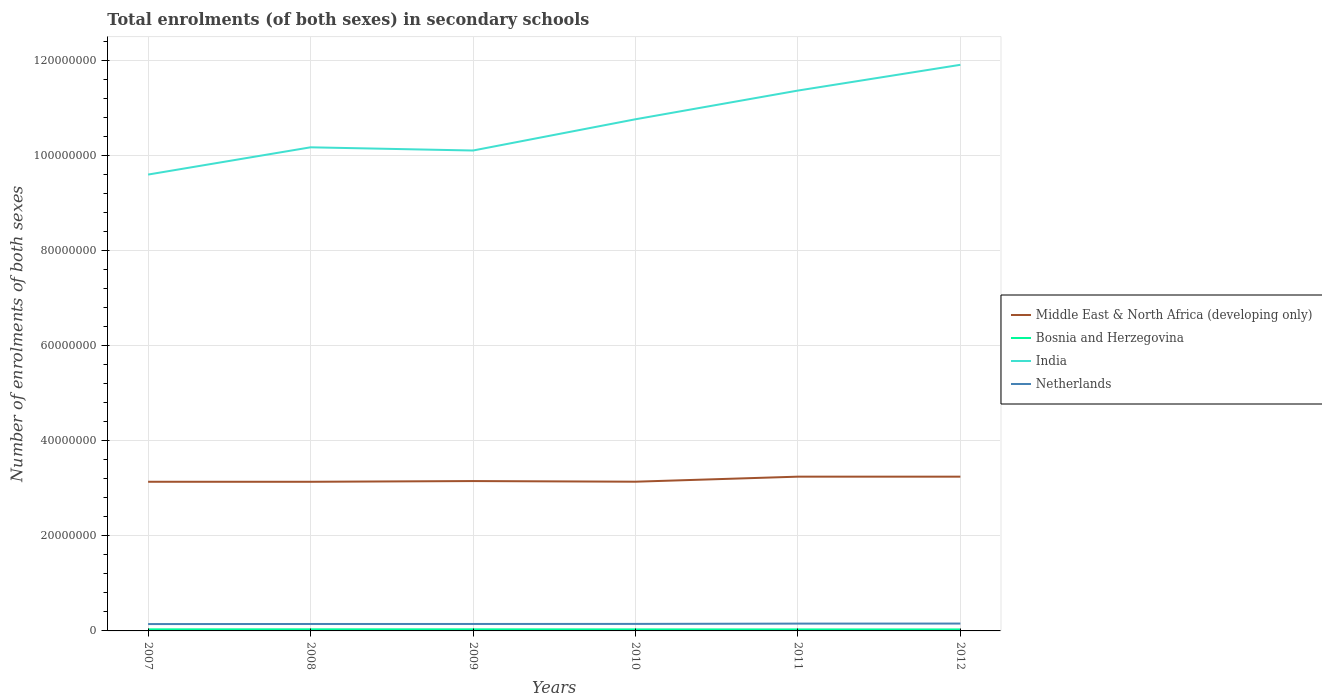How many different coloured lines are there?
Your answer should be very brief. 4. Is the number of lines equal to the number of legend labels?
Your response must be concise. Yes. Across all years, what is the maximum number of enrolments in secondary schools in Bosnia and Herzegovina?
Provide a succinct answer. 3.13e+05. What is the total number of enrolments in secondary schools in Netherlands in the graph?
Make the answer very short. -1.84e+04. What is the difference between the highest and the second highest number of enrolments in secondary schools in India?
Provide a short and direct response. 2.31e+07. How many lines are there?
Your response must be concise. 4. Are the values on the major ticks of Y-axis written in scientific E-notation?
Provide a succinct answer. No. Does the graph contain any zero values?
Make the answer very short. No. How are the legend labels stacked?
Offer a very short reply. Vertical. What is the title of the graph?
Ensure brevity in your answer.  Total enrolments (of both sexes) in secondary schools. Does "Samoa" appear as one of the legend labels in the graph?
Give a very brief answer. No. What is the label or title of the X-axis?
Offer a terse response. Years. What is the label or title of the Y-axis?
Give a very brief answer. Number of enrolments of both sexes. What is the Number of enrolments of both sexes in Middle East & North Africa (developing only) in 2007?
Your answer should be very brief. 3.14e+07. What is the Number of enrolments of both sexes in Bosnia and Herzegovina in 2007?
Give a very brief answer. 3.33e+05. What is the Number of enrolments of both sexes in India in 2007?
Offer a terse response. 9.60e+07. What is the Number of enrolments of both sexes of Netherlands in 2007?
Keep it short and to the point. 1.44e+06. What is the Number of enrolments of both sexes in Middle East & North Africa (developing only) in 2008?
Offer a terse response. 3.14e+07. What is the Number of enrolments of both sexes in Bosnia and Herzegovina in 2008?
Your answer should be compact. 3.39e+05. What is the Number of enrolments of both sexes in India in 2008?
Ensure brevity in your answer.  1.02e+08. What is the Number of enrolments of both sexes of Netherlands in 2008?
Offer a very short reply. 1.46e+06. What is the Number of enrolments of both sexes of Middle East & North Africa (developing only) in 2009?
Your answer should be very brief. 3.15e+07. What is the Number of enrolments of both sexes of Bosnia and Herzegovina in 2009?
Give a very brief answer. 3.34e+05. What is the Number of enrolments of both sexes in India in 2009?
Offer a terse response. 1.01e+08. What is the Number of enrolments of both sexes in Netherlands in 2009?
Your answer should be very brief. 1.46e+06. What is the Number of enrolments of both sexes in Middle East & North Africa (developing only) in 2010?
Keep it short and to the point. 3.14e+07. What is the Number of enrolments of both sexes of Bosnia and Herzegovina in 2010?
Your answer should be very brief. 3.23e+05. What is the Number of enrolments of both sexes of India in 2010?
Make the answer very short. 1.08e+08. What is the Number of enrolments of both sexes of Netherlands in 2010?
Offer a very short reply. 1.47e+06. What is the Number of enrolments of both sexes of Middle East & North Africa (developing only) in 2011?
Provide a succinct answer. 3.25e+07. What is the Number of enrolments of both sexes of Bosnia and Herzegovina in 2011?
Offer a terse response. 3.16e+05. What is the Number of enrolments of both sexes in India in 2011?
Offer a very short reply. 1.14e+08. What is the Number of enrolments of both sexes in Netherlands in 2011?
Offer a terse response. 1.54e+06. What is the Number of enrolments of both sexes in Middle East & North Africa (developing only) in 2012?
Provide a short and direct response. 3.25e+07. What is the Number of enrolments of both sexes of Bosnia and Herzegovina in 2012?
Provide a short and direct response. 3.13e+05. What is the Number of enrolments of both sexes in India in 2012?
Your answer should be very brief. 1.19e+08. What is the Number of enrolments of both sexes of Netherlands in 2012?
Give a very brief answer. 1.55e+06. Across all years, what is the maximum Number of enrolments of both sexes in Middle East & North Africa (developing only)?
Provide a succinct answer. 3.25e+07. Across all years, what is the maximum Number of enrolments of both sexes of Bosnia and Herzegovina?
Your response must be concise. 3.39e+05. Across all years, what is the maximum Number of enrolments of both sexes in India?
Your answer should be very brief. 1.19e+08. Across all years, what is the maximum Number of enrolments of both sexes of Netherlands?
Ensure brevity in your answer.  1.55e+06. Across all years, what is the minimum Number of enrolments of both sexes in Middle East & North Africa (developing only)?
Your answer should be very brief. 3.14e+07. Across all years, what is the minimum Number of enrolments of both sexes in Bosnia and Herzegovina?
Provide a short and direct response. 3.13e+05. Across all years, what is the minimum Number of enrolments of both sexes of India?
Provide a succinct answer. 9.60e+07. Across all years, what is the minimum Number of enrolments of both sexes of Netherlands?
Your response must be concise. 1.44e+06. What is the total Number of enrolments of both sexes in Middle East & North Africa (developing only) in the graph?
Offer a terse response. 1.91e+08. What is the total Number of enrolments of both sexes in Bosnia and Herzegovina in the graph?
Offer a very short reply. 1.96e+06. What is the total Number of enrolments of both sexes in India in the graph?
Your answer should be compact. 6.40e+08. What is the total Number of enrolments of both sexes in Netherlands in the graph?
Make the answer very short. 8.93e+06. What is the difference between the Number of enrolments of both sexes in Middle East & North Africa (developing only) in 2007 and that in 2008?
Make the answer very short. 4172. What is the difference between the Number of enrolments of both sexes in Bosnia and Herzegovina in 2007 and that in 2008?
Provide a short and direct response. -5667. What is the difference between the Number of enrolments of both sexes in India in 2007 and that in 2008?
Provide a succinct answer. -5.73e+06. What is the difference between the Number of enrolments of both sexes of Netherlands in 2007 and that in 2008?
Your answer should be very brief. -1.64e+04. What is the difference between the Number of enrolments of both sexes in Middle East & North Africa (developing only) in 2007 and that in 2009?
Provide a short and direct response. -1.48e+05. What is the difference between the Number of enrolments of both sexes in Bosnia and Herzegovina in 2007 and that in 2009?
Make the answer very short. -1051. What is the difference between the Number of enrolments of both sexes of India in 2007 and that in 2009?
Offer a terse response. -5.06e+06. What is the difference between the Number of enrolments of both sexes in Netherlands in 2007 and that in 2009?
Keep it short and to the point. -1.84e+04. What is the difference between the Number of enrolments of both sexes in Middle East & North Africa (developing only) in 2007 and that in 2010?
Make the answer very short. -1.16e+04. What is the difference between the Number of enrolments of both sexes in Bosnia and Herzegovina in 2007 and that in 2010?
Ensure brevity in your answer.  1.05e+04. What is the difference between the Number of enrolments of both sexes in India in 2007 and that in 2010?
Ensure brevity in your answer.  -1.16e+07. What is the difference between the Number of enrolments of both sexes in Netherlands in 2007 and that in 2010?
Give a very brief answer. -3.09e+04. What is the difference between the Number of enrolments of both sexes of Middle East & North Africa (developing only) in 2007 and that in 2011?
Offer a terse response. -1.08e+06. What is the difference between the Number of enrolments of both sexes of Bosnia and Herzegovina in 2007 and that in 2011?
Make the answer very short. 1.71e+04. What is the difference between the Number of enrolments of both sexes of India in 2007 and that in 2011?
Provide a short and direct response. -1.77e+07. What is the difference between the Number of enrolments of both sexes of Netherlands in 2007 and that in 2011?
Your response must be concise. -9.48e+04. What is the difference between the Number of enrolments of both sexes in Middle East & North Africa (developing only) in 2007 and that in 2012?
Offer a terse response. -1.07e+06. What is the difference between the Number of enrolments of both sexes of Bosnia and Herzegovina in 2007 and that in 2012?
Make the answer very short. 2.00e+04. What is the difference between the Number of enrolments of both sexes in India in 2007 and that in 2012?
Give a very brief answer. -2.31e+07. What is the difference between the Number of enrolments of both sexes of Netherlands in 2007 and that in 2012?
Your answer should be compact. -1.06e+05. What is the difference between the Number of enrolments of both sexes of Middle East & North Africa (developing only) in 2008 and that in 2009?
Offer a terse response. -1.52e+05. What is the difference between the Number of enrolments of both sexes in Bosnia and Herzegovina in 2008 and that in 2009?
Give a very brief answer. 4616. What is the difference between the Number of enrolments of both sexes in India in 2008 and that in 2009?
Your response must be concise. 6.74e+05. What is the difference between the Number of enrolments of both sexes of Netherlands in 2008 and that in 2009?
Ensure brevity in your answer.  -1958. What is the difference between the Number of enrolments of both sexes in Middle East & North Africa (developing only) in 2008 and that in 2010?
Provide a succinct answer. -1.58e+04. What is the difference between the Number of enrolments of both sexes of Bosnia and Herzegovina in 2008 and that in 2010?
Give a very brief answer. 1.62e+04. What is the difference between the Number of enrolments of both sexes of India in 2008 and that in 2010?
Your answer should be very brief. -5.90e+06. What is the difference between the Number of enrolments of both sexes in Netherlands in 2008 and that in 2010?
Offer a terse response. -1.45e+04. What is the difference between the Number of enrolments of both sexes of Middle East & North Africa (developing only) in 2008 and that in 2011?
Your answer should be very brief. -1.08e+06. What is the difference between the Number of enrolments of both sexes of Bosnia and Herzegovina in 2008 and that in 2011?
Provide a short and direct response. 2.27e+04. What is the difference between the Number of enrolments of both sexes in India in 2008 and that in 2011?
Keep it short and to the point. -1.19e+07. What is the difference between the Number of enrolments of both sexes of Netherlands in 2008 and that in 2011?
Your answer should be very brief. -7.84e+04. What is the difference between the Number of enrolments of both sexes in Middle East & North Africa (developing only) in 2008 and that in 2012?
Make the answer very short. -1.08e+06. What is the difference between the Number of enrolments of both sexes of Bosnia and Herzegovina in 2008 and that in 2012?
Your answer should be very brief. 2.56e+04. What is the difference between the Number of enrolments of both sexes in India in 2008 and that in 2012?
Give a very brief answer. -1.74e+07. What is the difference between the Number of enrolments of both sexes of Netherlands in 2008 and that in 2012?
Your answer should be compact. -8.97e+04. What is the difference between the Number of enrolments of both sexes of Middle East & North Africa (developing only) in 2009 and that in 2010?
Give a very brief answer. 1.36e+05. What is the difference between the Number of enrolments of both sexes in Bosnia and Herzegovina in 2009 and that in 2010?
Offer a terse response. 1.16e+04. What is the difference between the Number of enrolments of both sexes in India in 2009 and that in 2010?
Your answer should be very brief. -6.58e+06. What is the difference between the Number of enrolments of both sexes in Netherlands in 2009 and that in 2010?
Keep it short and to the point. -1.25e+04. What is the difference between the Number of enrolments of both sexes of Middle East & North Africa (developing only) in 2009 and that in 2011?
Offer a terse response. -9.28e+05. What is the difference between the Number of enrolments of both sexes in Bosnia and Herzegovina in 2009 and that in 2011?
Keep it short and to the point. 1.81e+04. What is the difference between the Number of enrolments of both sexes in India in 2009 and that in 2011?
Offer a very short reply. -1.26e+07. What is the difference between the Number of enrolments of both sexes in Netherlands in 2009 and that in 2011?
Your answer should be compact. -7.64e+04. What is the difference between the Number of enrolments of both sexes in Middle East & North Africa (developing only) in 2009 and that in 2012?
Provide a short and direct response. -9.24e+05. What is the difference between the Number of enrolments of both sexes in Bosnia and Herzegovina in 2009 and that in 2012?
Offer a very short reply. 2.10e+04. What is the difference between the Number of enrolments of both sexes of India in 2009 and that in 2012?
Provide a succinct answer. -1.80e+07. What is the difference between the Number of enrolments of both sexes in Netherlands in 2009 and that in 2012?
Give a very brief answer. -8.77e+04. What is the difference between the Number of enrolments of both sexes in Middle East & North Africa (developing only) in 2010 and that in 2011?
Ensure brevity in your answer.  -1.06e+06. What is the difference between the Number of enrolments of both sexes of Bosnia and Herzegovina in 2010 and that in 2011?
Your answer should be very brief. 6525. What is the difference between the Number of enrolments of both sexes of India in 2010 and that in 2011?
Keep it short and to the point. -6.04e+06. What is the difference between the Number of enrolments of both sexes of Netherlands in 2010 and that in 2011?
Your response must be concise. -6.39e+04. What is the difference between the Number of enrolments of both sexes in Middle East & North Africa (developing only) in 2010 and that in 2012?
Your answer should be compact. -1.06e+06. What is the difference between the Number of enrolments of both sexes in Bosnia and Herzegovina in 2010 and that in 2012?
Provide a succinct answer. 9445. What is the difference between the Number of enrolments of both sexes in India in 2010 and that in 2012?
Offer a terse response. -1.15e+07. What is the difference between the Number of enrolments of both sexes of Netherlands in 2010 and that in 2012?
Give a very brief answer. -7.52e+04. What is the difference between the Number of enrolments of both sexes in Middle East & North Africa (developing only) in 2011 and that in 2012?
Your response must be concise. 3830. What is the difference between the Number of enrolments of both sexes of Bosnia and Herzegovina in 2011 and that in 2012?
Ensure brevity in your answer.  2920. What is the difference between the Number of enrolments of both sexes of India in 2011 and that in 2012?
Your answer should be very brief. -5.42e+06. What is the difference between the Number of enrolments of both sexes of Netherlands in 2011 and that in 2012?
Offer a very short reply. -1.13e+04. What is the difference between the Number of enrolments of both sexes in Middle East & North Africa (developing only) in 2007 and the Number of enrolments of both sexes in Bosnia and Herzegovina in 2008?
Make the answer very short. 3.11e+07. What is the difference between the Number of enrolments of both sexes of Middle East & North Africa (developing only) in 2007 and the Number of enrolments of both sexes of India in 2008?
Offer a very short reply. -7.04e+07. What is the difference between the Number of enrolments of both sexes of Middle East & North Africa (developing only) in 2007 and the Number of enrolments of both sexes of Netherlands in 2008?
Provide a succinct answer. 2.99e+07. What is the difference between the Number of enrolments of both sexes of Bosnia and Herzegovina in 2007 and the Number of enrolments of both sexes of India in 2008?
Make the answer very short. -1.01e+08. What is the difference between the Number of enrolments of both sexes of Bosnia and Herzegovina in 2007 and the Number of enrolments of both sexes of Netherlands in 2008?
Make the answer very short. -1.13e+06. What is the difference between the Number of enrolments of both sexes in India in 2007 and the Number of enrolments of both sexes in Netherlands in 2008?
Keep it short and to the point. 9.46e+07. What is the difference between the Number of enrolments of both sexes of Middle East & North Africa (developing only) in 2007 and the Number of enrolments of both sexes of Bosnia and Herzegovina in 2009?
Your answer should be compact. 3.11e+07. What is the difference between the Number of enrolments of both sexes in Middle East & North Africa (developing only) in 2007 and the Number of enrolments of both sexes in India in 2009?
Your answer should be very brief. -6.97e+07. What is the difference between the Number of enrolments of both sexes in Middle East & North Africa (developing only) in 2007 and the Number of enrolments of both sexes in Netherlands in 2009?
Ensure brevity in your answer.  2.99e+07. What is the difference between the Number of enrolments of both sexes in Bosnia and Herzegovina in 2007 and the Number of enrolments of both sexes in India in 2009?
Your answer should be very brief. -1.01e+08. What is the difference between the Number of enrolments of both sexes of Bosnia and Herzegovina in 2007 and the Number of enrolments of both sexes of Netherlands in 2009?
Offer a very short reply. -1.13e+06. What is the difference between the Number of enrolments of both sexes in India in 2007 and the Number of enrolments of both sexes in Netherlands in 2009?
Give a very brief answer. 9.46e+07. What is the difference between the Number of enrolments of both sexes of Middle East & North Africa (developing only) in 2007 and the Number of enrolments of both sexes of Bosnia and Herzegovina in 2010?
Keep it short and to the point. 3.11e+07. What is the difference between the Number of enrolments of both sexes of Middle East & North Africa (developing only) in 2007 and the Number of enrolments of both sexes of India in 2010?
Your answer should be very brief. -7.63e+07. What is the difference between the Number of enrolments of both sexes in Middle East & North Africa (developing only) in 2007 and the Number of enrolments of both sexes in Netherlands in 2010?
Offer a very short reply. 2.99e+07. What is the difference between the Number of enrolments of both sexes in Bosnia and Herzegovina in 2007 and the Number of enrolments of both sexes in India in 2010?
Your response must be concise. -1.07e+08. What is the difference between the Number of enrolments of both sexes of Bosnia and Herzegovina in 2007 and the Number of enrolments of both sexes of Netherlands in 2010?
Ensure brevity in your answer.  -1.14e+06. What is the difference between the Number of enrolments of both sexes of India in 2007 and the Number of enrolments of both sexes of Netherlands in 2010?
Give a very brief answer. 9.46e+07. What is the difference between the Number of enrolments of both sexes in Middle East & North Africa (developing only) in 2007 and the Number of enrolments of both sexes in Bosnia and Herzegovina in 2011?
Keep it short and to the point. 3.11e+07. What is the difference between the Number of enrolments of both sexes in Middle East & North Africa (developing only) in 2007 and the Number of enrolments of both sexes in India in 2011?
Provide a short and direct response. -8.23e+07. What is the difference between the Number of enrolments of both sexes in Middle East & North Africa (developing only) in 2007 and the Number of enrolments of both sexes in Netherlands in 2011?
Ensure brevity in your answer.  2.99e+07. What is the difference between the Number of enrolments of both sexes of Bosnia and Herzegovina in 2007 and the Number of enrolments of both sexes of India in 2011?
Give a very brief answer. -1.13e+08. What is the difference between the Number of enrolments of both sexes of Bosnia and Herzegovina in 2007 and the Number of enrolments of both sexes of Netherlands in 2011?
Offer a terse response. -1.21e+06. What is the difference between the Number of enrolments of both sexes of India in 2007 and the Number of enrolments of both sexes of Netherlands in 2011?
Your answer should be compact. 9.45e+07. What is the difference between the Number of enrolments of both sexes of Middle East & North Africa (developing only) in 2007 and the Number of enrolments of both sexes of Bosnia and Herzegovina in 2012?
Your answer should be compact. 3.11e+07. What is the difference between the Number of enrolments of both sexes of Middle East & North Africa (developing only) in 2007 and the Number of enrolments of both sexes of India in 2012?
Your response must be concise. -8.78e+07. What is the difference between the Number of enrolments of both sexes in Middle East & North Africa (developing only) in 2007 and the Number of enrolments of both sexes in Netherlands in 2012?
Your answer should be compact. 2.98e+07. What is the difference between the Number of enrolments of both sexes in Bosnia and Herzegovina in 2007 and the Number of enrolments of both sexes in India in 2012?
Offer a terse response. -1.19e+08. What is the difference between the Number of enrolments of both sexes of Bosnia and Herzegovina in 2007 and the Number of enrolments of both sexes of Netherlands in 2012?
Provide a short and direct response. -1.22e+06. What is the difference between the Number of enrolments of both sexes of India in 2007 and the Number of enrolments of both sexes of Netherlands in 2012?
Your answer should be compact. 9.45e+07. What is the difference between the Number of enrolments of both sexes of Middle East & North Africa (developing only) in 2008 and the Number of enrolments of both sexes of Bosnia and Herzegovina in 2009?
Ensure brevity in your answer.  3.11e+07. What is the difference between the Number of enrolments of both sexes in Middle East & North Africa (developing only) in 2008 and the Number of enrolments of both sexes in India in 2009?
Offer a very short reply. -6.97e+07. What is the difference between the Number of enrolments of both sexes of Middle East & North Africa (developing only) in 2008 and the Number of enrolments of both sexes of Netherlands in 2009?
Keep it short and to the point. 2.99e+07. What is the difference between the Number of enrolments of both sexes in Bosnia and Herzegovina in 2008 and the Number of enrolments of both sexes in India in 2009?
Your response must be concise. -1.01e+08. What is the difference between the Number of enrolments of both sexes in Bosnia and Herzegovina in 2008 and the Number of enrolments of both sexes in Netherlands in 2009?
Keep it short and to the point. -1.12e+06. What is the difference between the Number of enrolments of both sexes in India in 2008 and the Number of enrolments of both sexes in Netherlands in 2009?
Offer a terse response. 1.00e+08. What is the difference between the Number of enrolments of both sexes of Middle East & North Africa (developing only) in 2008 and the Number of enrolments of both sexes of Bosnia and Herzegovina in 2010?
Offer a terse response. 3.11e+07. What is the difference between the Number of enrolments of both sexes in Middle East & North Africa (developing only) in 2008 and the Number of enrolments of both sexes in India in 2010?
Your response must be concise. -7.63e+07. What is the difference between the Number of enrolments of both sexes of Middle East & North Africa (developing only) in 2008 and the Number of enrolments of both sexes of Netherlands in 2010?
Ensure brevity in your answer.  2.99e+07. What is the difference between the Number of enrolments of both sexes of Bosnia and Herzegovina in 2008 and the Number of enrolments of both sexes of India in 2010?
Make the answer very short. -1.07e+08. What is the difference between the Number of enrolments of both sexes of Bosnia and Herzegovina in 2008 and the Number of enrolments of both sexes of Netherlands in 2010?
Provide a short and direct response. -1.14e+06. What is the difference between the Number of enrolments of both sexes in India in 2008 and the Number of enrolments of both sexes in Netherlands in 2010?
Your response must be concise. 1.00e+08. What is the difference between the Number of enrolments of both sexes of Middle East & North Africa (developing only) in 2008 and the Number of enrolments of both sexes of Bosnia and Herzegovina in 2011?
Provide a short and direct response. 3.11e+07. What is the difference between the Number of enrolments of both sexes of Middle East & North Africa (developing only) in 2008 and the Number of enrolments of both sexes of India in 2011?
Provide a short and direct response. -8.23e+07. What is the difference between the Number of enrolments of both sexes of Middle East & North Africa (developing only) in 2008 and the Number of enrolments of both sexes of Netherlands in 2011?
Your answer should be very brief. 2.98e+07. What is the difference between the Number of enrolments of both sexes of Bosnia and Herzegovina in 2008 and the Number of enrolments of both sexes of India in 2011?
Ensure brevity in your answer.  -1.13e+08. What is the difference between the Number of enrolments of both sexes in Bosnia and Herzegovina in 2008 and the Number of enrolments of both sexes in Netherlands in 2011?
Make the answer very short. -1.20e+06. What is the difference between the Number of enrolments of both sexes in India in 2008 and the Number of enrolments of both sexes in Netherlands in 2011?
Provide a short and direct response. 1.00e+08. What is the difference between the Number of enrolments of both sexes in Middle East & North Africa (developing only) in 2008 and the Number of enrolments of both sexes in Bosnia and Herzegovina in 2012?
Provide a short and direct response. 3.11e+07. What is the difference between the Number of enrolments of both sexes of Middle East & North Africa (developing only) in 2008 and the Number of enrolments of both sexes of India in 2012?
Provide a short and direct response. -8.78e+07. What is the difference between the Number of enrolments of both sexes of Middle East & North Africa (developing only) in 2008 and the Number of enrolments of both sexes of Netherlands in 2012?
Make the answer very short. 2.98e+07. What is the difference between the Number of enrolments of both sexes of Bosnia and Herzegovina in 2008 and the Number of enrolments of both sexes of India in 2012?
Your answer should be very brief. -1.19e+08. What is the difference between the Number of enrolments of both sexes of Bosnia and Herzegovina in 2008 and the Number of enrolments of both sexes of Netherlands in 2012?
Ensure brevity in your answer.  -1.21e+06. What is the difference between the Number of enrolments of both sexes of India in 2008 and the Number of enrolments of both sexes of Netherlands in 2012?
Make the answer very short. 1.00e+08. What is the difference between the Number of enrolments of both sexes of Middle East & North Africa (developing only) in 2009 and the Number of enrolments of both sexes of Bosnia and Herzegovina in 2010?
Provide a succinct answer. 3.12e+07. What is the difference between the Number of enrolments of both sexes in Middle East & North Africa (developing only) in 2009 and the Number of enrolments of both sexes in India in 2010?
Provide a succinct answer. -7.61e+07. What is the difference between the Number of enrolments of both sexes of Middle East & North Africa (developing only) in 2009 and the Number of enrolments of both sexes of Netherlands in 2010?
Make the answer very short. 3.01e+07. What is the difference between the Number of enrolments of both sexes in Bosnia and Herzegovina in 2009 and the Number of enrolments of both sexes in India in 2010?
Offer a terse response. -1.07e+08. What is the difference between the Number of enrolments of both sexes of Bosnia and Herzegovina in 2009 and the Number of enrolments of both sexes of Netherlands in 2010?
Your answer should be compact. -1.14e+06. What is the difference between the Number of enrolments of both sexes in India in 2009 and the Number of enrolments of both sexes in Netherlands in 2010?
Provide a short and direct response. 9.96e+07. What is the difference between the Number of enrolments of both sexes of Middle East & North Africa (developing only) in 2009 and the Number of enrolments of both sexes of Bosnia and Herzegovina in 2011?
Your answer should be compact. 3.12e+07. What is the difference between the Number of enrolments of both sexes of Middle East & North Africa (developing only) in 2009 and the Number of enrolments of both sexes of India in 2011?
Offer a terse response. -8.22e+07. What is the difference between the Number of enrolments of both sexes of Middle East & North Africa (developing only) in 2009 and the Number of enrolments of both sexes of Netherlands in 2011?
Offer a terse response. 3.00e+07. What is the difference between the Number of enrolments of both sexes of Bosnia and Herzegovina in 2009 and the Number of enrolments of both sexes of India in 2011?
Give a very brief answer. -1.13e+08. What is the difference between the Number of enrolments of both sexes of Bosnia and Herzegovina in 2009 and the Number of enrolments of both sexes of Netherlands in 2011?
Your response must be concise. -1.20e+06. What is the difference between the Number of enrolments of both sexes in India in 2009 and the Number of enrolments of both sexes in Netherlands in 2011?
Your answer should be very brief. 9.96e+07. What is the difference between the Number of enrolments of both sexes in Middle East & North Africa (developing only) in 2009 and the Number of enrolments of both sexes in Bosnia and Herzegovina in 2012?
Make the answer very short. 3.12e+07. What is the difference between the Number of enrolments of both sexes in Middle East & North Africa (developing only) in 2009 and the Number of enrolments of both sexes in India in 2012?
Your response must be concise. -8.76e+07. What is the difference between the Number of enrolments of both sexes of Middle East & North Africa (developing only) in 2009 and the Number of enrolments of both sexes of Netherlands in 2012?
Make the answer very short. 3.00e+07. What is the difference between the Number of enrolments of both sexes in Bosnia and Herzegovina in 2009 and the Number of enrolments of both sexes in India in 2012?
Your response must be concise. -1.19e+08. What is the difference between the Number of enrolments of both sexes in Bosnia and Herzegovina in 2009 and the Number of enrolments of both sexes in Netherlands in 2012?
Your answer should be compact. -1.22e+06. What is the difference between the Number of enrolments of both sexes in India in 2009 and the Number of enrolments of both sexes in Netherlands in 2012?
Give a very brief answer. 9.96e+07. What is the difference between the Number of enrolments of both sexes in Middle East & North Africa (developing only) in 2010 and the Number of enrolments of both sexes in Bosnia and Herzegovina in 2011?
Your answer should be compact. 3.11e+07. What is the difference between the Number of enrolments of both sexes in Middle East & North Africa (developing only) in 2010 and the Number of enrolments of both sexes in India in 2011?
Your answer should be very brief. -8.23e+07. What is the difference between the Number of enrolments of both sexes in Middle East & North Africa (developing only) in 2010 and the Number of enrolments of both sexes in Netherlands in 2011?
Offer a terse response. 2.99e+07. What is the difference between the Number of enrolments of both sexes in Bosnia and Herzegovina in 2010 and the Number of enrolments of both sexes in India in 2011?
Offer a terse response. -1.13e+08. What is the difference between the Number of enrolments of both sexes in Bosnia and Herzegovina in 2010 and the Number of enrolments of both sexes in Netherlands in 2011?
Provide a succinct answer. -1.22e+06. What is the difference between the Number of enrolments of both sexes of India in 2010 and the Number of enrolments of both sexes of Netherlands in 2011?
Provide a short and direct response. 1.06e+08. What is the difference between the Number of enrolments of both sexes in Middle East & North Africa (developing only) in 2010 and the Number of enrolments of both sexes in Bosnia and Herzegovina in 2012?
Make the answer very short. 3.11e+07. What is the difference between the Number of enrolments of both sexes of Middle East & North Africa (developing only) in 2010 and the Number of enrolments of both sexes of India in 2012?
Offer a very short reply. -8.77e+07. What is the difference between the Number of enrolments of both sexes in Middle East & North Africa (developing only) in 2010 and the Number of enrolments of both sexes in Netherlands in 2012?
Your answer should be very brief. 2.99e+07. What is the difference between the Number of enrolments of both sexes in Bosnia and Herzegovina in 2010 and the Number of enrolments of both sexes in India in 2012?
Offer a very short reply. -1.19e+08. What is the difference between the Number of enrolments of both sexes of Bosnia and Herzegovina in 2010 and the Number of enrolments of both sexes of Netherlands in 2012?
Your answer should be very brief. -1.23e+06. What is the difference between the Number of enrolments of both sexes in India in 2010 and the Number of enrolments of both sexes in Netherlands in 2012?
Ensure brevity in your answer.  1.06e+08. What is the difference between the Number of enrolments of both sexes in Middle East & North Africa (developing only) in 2011 and the Number of enrolments of both sexes in Bosnia and Herzegovina in 2012?
Your response must be concise. 3.22e+07. What is the difference between the Number of enrolments of both sexes of Middle East & North Africa (developing only) in 2011 and the Number of enrolments of both sexes of India in 2012?
Keep it short and to the point. -8.67e+07. What is the difference between the Number of enrolments of both sexes in Middle East & North Africa (developing only) in 2011 and the Number of enrolments of both sexes in Netherlands in 2012?
Provide a succinct answer. 3.09e+07. What is the difference between the Number of enrolments of both sexes in Bosnia and Herzegovina in 2011 and the Number of enrolments of both sexes in India in 2012?
Offer a terse response. -1.19e+08. What is the difference between the Number of enrolments of both sexes in Bosnia and Herzegovina in 2011 and the Number of enrolments of both sexes in Netherlands in 2012?
Your response must be concise. -1.23e+06. What is the difference between the Number of enrolments of both sexes in India in 2011 and the Number of enrolments of both sexes in Netherlands in 2012?
Ensure brevity in your answer.  1.12e+08. What is the average Number of enrolments of both sexes in Middle East & North Africa (developing only) per year?
Offer a very short reply. 3.18e+07. What is the average Number of enrolments of both sexes in Bosnia and Herzegovina per year?
Ensure brevity in your answer.  3.26e+05. What is the average Number of enrolments of both sexes in India per year?
Keep it short and to the point. 1.07e+08. What is the average Number of enrolments of both sexes in Netherlands per year?
Your answer should be compact. 1.49e+06. In the year 2007, what is the difference between the Number of enrolments of both sexes in Middle East & North Africa (developing only) and Number of enrolments of both sexes in Bosnia and Herzegovina?
Make the answer very short. 3.11e+07. In the year 2007, what is the difference between the Number of enrolments of both sexes in Middle East & North Africa (developing only) and Number of enrolments of both sexes in India?
Your response must be concise. -6.47e+07. In the year 2007, what is the difference between the Number of enrolments of both sexes of Middle East & North Africa (developing only) and Number of enrolments of both sexes of Netherlands?
Offer a terse response. 2.99e+07. In the year 2007, what is the difference between the Number of enrolments of both sexes of Bosnia and Herzegovina and Number of enrolments of both sexes of India?
Make the answer very short. -9.57e+07. In the year 2007, what is the difference between the Number of enrolments of both sexes in Bosnia and Herzegovina and Number of enrolments of both sexes in Netherlands?
Provide a succinct answer. -1.11e+06. In the year 2007, what is the difference between the Number of enrolments of both sexes in India and Number of enrolments of both sexes in Netherlands?
Provide a succinct answer. 9.46e+07. In the year 2008, what is the difference between the Number of enrolments of both sexes in Middle East & North Africa (developing only) and Number of enrolments of both sexes in Bosnia and Herzegovina?
Your answer should be very brief. 3.10e+07. In the year 2008, what is the difference between the Number of enrolments of both sexes of Middle East & North Africa (developing only) and Number of enrolments of both sexes of India?
Your response must be concise. -7.04e+07. In the year 2008, what is the difference between the Number of enrolments of both sexes in Middle East & North Africa (developing only) and Number of enrolments of both sexes in Netherlands?
Ensure brevity in your answer.  2.99e+07. In the year 2008, what is the difference between the Number of enrolments of both sexes in Bosnia and Herzegovina and Number of enrolments of both sexes in India?
Your response must be concise. -1.01e+08. In the year 2008, what is the difference between the Number of enrolments of both sexes of Bosnia and Herzegovina and Number of enrolments of both sexes of Netherlands?
Your answer should be very brief. -1.12e+06. In the year 2008, what is the difference between the Number of enrolments of both sexes of India and Number of enrolments of both sexes of Netherlands?
Offer a very short reply. 1.00e+08. In the year 2009, what is the difference between the Number of enrolments of both sexes in Middle East & North Africa (developing only) and Number of enrolments of both sexes in Bosnia and Herzegovina?
Keep it short and to the point. 3.12e+07. In the year 2009, what is the difference between the Number of enrolments of both sexes in Middle East & North Africa (developing only) and Number of enrolments of both sexes in India?
Your answer should be very brief. -6.96e+07. In the year 2009, what is the difference between the Number of enrolments of both sexes in Middle East & North Africa (developing only) and Number of enrolments of both sexes in Netherlands?
Give a very brief answer. 3.01e+07. In the year 2009, what is the difference between the Number of enrolments of both sexes of Bosnia and Herzegovina and Number of enrolments of both sexes of India?
Your answer should be compact. -1.01e+08. In the year 2009, what is the difference between the Number of enrolments of both sexes of Bosnia and Herzegovina and Number of enrolments of both sexes of Netherlands?
Give a very brief answer. -1.13e+06. In the year 2009, what is the difference between the Number of enrolments of both sexes of India and Number of enrolments of both sexes of Netherlands?
Provide a succinct answer. 9.96e+07. In the year 2010, what is the difference between the Number of enrolments of both sexes of Middle East & North Africa (developing only) and Number of enrolments of both sexes of Bosnia and Herzegovina?
Ensure brevity in your answer.  3.11e+07. In the year 2010, what is the difference between the Number of enrolments of both sexes of Middle East & North Africa (developing only) and Number of enrolments of both sexes of India?
Provide a succinct answer. -7.63e+07. In the year 2010, what is the difference between the Number of enrolments of both sexes in Middle East & North Africa (developing only) and Number of enrolments of both sexes in Netherlands?
Give a very brief answer. 2.99e+07. In the year 2010, what is the difference between the Number of enrolments of both sexes of Bosnia and Herzegovina and Number of enrolments of both sexes of India?
Provide a short and direct response. -1.07e+08. In the year 2010, what is the difference between the Number of enrolments of both sexes of Bosnia and Herzegovina and Number of enrolments of both sexes of Netherlands?
Make the answer very short. -1.15e+06. In the year 2010, what is the difference between the Number of enrolments of both sexes of India and Number of enrolments of both sexes of Netherlands?
Keep it short and to the point. 1.06e+08. In the year 2011, what is the difference between the Number of enrolments of both sexes of Middle East & North Africa (developing only) and Number of enrolments of both sexes of Bosnia and Herzegovina?
Keep it short and to the point. 3.22e+07. In the year 2011, what is the difference between the Number of enrolments of both sexes in Middle East & North Africa (developing only) and Number of enrolments of both sexes in India?
Ensure brevity in your answer.  -8.13e+07. In the year 2011, what is the difference between the Number of enrolments of both sexes of Middle East & North Africa (developing only) and Number of enrolments of both sexes of Netherlands?
Your response must be concise. 3.09e+07. In the year 2011, what is the difference between the Number of enrolments of both sexes of Bosnia and Herzegovina and Number of enrolments of both sexes of India?
Make the answer very short. -1.13e+08. In the year 2011, what is the difference between the Number of enrolments of both sexes of Bosnia and Herzegovina and Number of enrolments of both sexes of Netherlands?
Your answer should be compact. -1.22e+06. In the year 2011, what is the difference between the Number of enrolments of both sexes of India and Number of enrolments of both sexes of Netherlands?
Make the answer very short. 1.12e+08. In the year 2012, what is the difference between the Number of enrolments of both sexes of Middle East & North Africa (developing only) and Number of enrolments of both sexes of Bosnia and Herzegovina?
Your answer should be very brief. 3.22e+07. In the year 2012, what is the difference between the Number of enrolments of both sexes of Middle East & North Africa (developing only) and Number of enrolments of both sexes of India?
Offer a very short reply. -8.67e+07. In the year 2012, what is the difference between the Number of enrolments of both sexes of Middle East & North Africa (developing only) and Number of enrolments of both sexes of Netherlands?
Provide a succinct answer. 3.09e+07. In the year 2012, what is the difference between the Number of enrolments of both sexes of Bosnia and Herzegovina and Number of enrolments of both sexes of India?
Your answer should be very brief. -1.19e+08. In the year 2012, what is the difference between the Number of enrolments of both sexes in Bosnia and Herzegovina and Number of enrolments of both sexes in Netherlands?
Provide a succinct answer. -1.24e+06. In the year 2012, what is the difference between the Number of enrolments of both sexes in India and Number of enrolments of both sexes in Netherlands?
Keep it short and to the point. 1.18e+08. What is the ratio of the Number of enrolments of both sexes of Bosnia and Herzegovina in 2007 to that in 2008?
Keep it short and to the point. 0.98. What is the ratio of the Number of enrolments of both sexes in India in 2007 to that in 2008?
Your answer should be compact. 0.94. What is the ratio of the Number of enrolments of both sexes of Netherlands in 2007 to that in 2008?
Provide a short and direct response. 0.99. What is the ratio of the Number of enrolments of both sexes of Middle East & North Africa (developing only) in 2007 to that in 2009?
Your answer should be compact. 1. What is the ratio of the Number of enrolments of both sexes in India in 2007 to that in 2009?
Your answer should be very brief. 0.95. What is the ratio of the Number of enrolments of both sexes in Netherlands in 2007 to that in 2009?
Keep it short and to the point. 0.99. What is the ratio of the Number of enrolments of both sexes in Bosnia and Herzegovina in 2007 to that in 2010?
Keep it short and to the point. 1.03. What is the ratio of the Number of enrolments of both sexes in India in 2007 to that in 2010?
Offer a terse response. 0.89. What is the ratio of the Number of enrolments of both sexes of Netherlands in 2007 to that in 2010?
Provide a succinct answer. 0.98. What is the ratio of the Number of enrolments of both sexes in Middle East & North Africa (developing only) in 2007 to that in 2011?
Your answer should be very brief. 0.97. What is the ratio of the Number of enrolments of both sexes of Bosnia and Herzegovina in 2007 to that in 2011?
Make the answer very short. 1.05. What is the ratio of the Number of enrolments of both sexes of India in 2007 to that in 2011?
Ensure brevity in your answer.  0.84. What is the ratio of the Number of enrolments of both sexes of Netherlands in 2007 to that in 2011?
Ensure brevity in your answer.  0.94. What is the ratio of the Number of enrolments of both sexes in Middle East & North Africa (developing only) in 2007 to that in 2012?
Offer a very short reply. 0.97. What is the ratio of the Number of enrolments of both sexes in Bosnia and Herzegovina in 2007 to that in 2012?
Provide a short and direct response. 1.06. What is the ratio of the Number of enrolments of both sexes in India in 2007 to that in 2012?
Give a very brief answer. 0.81. What is the ratio of the Number of enrolments of both sexes in Netherlands in 2007 to that in 2012?
Your answer should be compact. 0.93. What is the ratio of the Number of enrolments of both sexes in Middle East & North Africa (developing only) in 2008 to that in 2009?
Your answer should be very brief. 1. What is the ratio of the Number of enrolments of both sexes of Bosnia and Herzegovina in 2008 to that in 2009?
Offer a terse response. 1.01. What is the ratio of the Number of enrolments of both sexes in Middle East & North Africa (developing only) in 2008 to that in 2010?
Provide a short and direct response. 1. What is the ratio of the Number of enrolments of both sexes in Bosnia and Herzegovina in 2008 to that in 2010?
Provide a short and direct response. 1.05. What is the ratio of the Number of enrolments of both sexes in India in 2008 to that in 2010?
Your answer should be compact. 0.95. What is the ratio of the Number of enrolments of both sexes of Netherlands in 2008 to that in 2010?
Provide a short and direct response. 0.99. What is the ratio of the Number of enrolments of both sexes of Middle East & North Africa (developing only) in 2008 to that in 2011?
Provide a short and direct response. 0.97. What is the ratio of the Number of enrolments of both sexes in Bosnia and Herzegovina in 2008 to that in 2011?
Keep it short and to the point. 1.07. What is the ratio of the Number of enrolments of both sexes in India in 2008 to that in 2011?
Your response must be concise. 0.9. What is the ratio of the Number of enrolments of both sexes in Netherlands in 2008 to that in 2011?
Provide a succinct answer. 0.95. What is the ratio of the Number of enrolments of both sexes in Middle East & North Africa (developing only) in 2008 to that in 2012?
Give a very brief answer. 0.97. What is the ratio of the Number of enrolments of both sexes in Bosnia and Herzegovina in 2008 to that in 2012?
Offer a very short reply. 1.08. What is the ratio of the Number of enrolments of both sexes in India in 2008 to that in 2012?
Give a very brief answer. 0.85. What is the ratio of the Number of enrolments of both sexes in Netherlands in 2008 to that in 2012?
Ensure brevity in your answer.  0.94. What is the ratio of the Number of enrolments of both sexes in Bosnia and Herzegovina in 2009 to that in 2010?
Offer a very short reply. 1.04. What is the ratio of the Number of enrolments of both sexes of India in 2009 to that in 2010?
Give a very brief answer. 0.94. What is the ratio of the Number of enrolments of both sexes in Netherlands in 2009 to that in 2010?
Your answer should be very brief. 0.99. What is the ratio of the Number of enrolments of both sexes of Middle East & North Africa (developing only) in 2009 to that in 2011?
Provide a short and direct response. 0.97. What is the ratio of the Number of enrolments of both sexes of Bosnia and Herzegovina in 2009 to that in 2011?
Offer a very short reply. 1.06. What is the ratio of the Number of enrolments of both sexes of India in 2009 to that in 2011?
Provide a short and direct response. 0.89. What is the ratio of the Number of enrolments of both sexes of Netherlands in 2009 to that in 2011?
Offer a terse response. 0.95. What is the ratio of the Number of enrolments of both sexes in Middle East & North Africa (developing only) in 2009 to that in 2012?
Offer a terse response. 0.97. What is the ratio of the Number of enrolments of both sexes in Bosnia and Herzegovina in 2009 to that in 2012?
Your response must be concise. 1.07. What is the ratio of the Number of enrolments of both sexes in India in 2009 to that in 2012?
Your answer should be compact. 0.85. What is the ratio of the Number of enrolments of both sexes in Netherlands in 2009 to that in 2012?
Ensure brevity in your answer.  0.94. What is the ratio of the Number of enrolments of both sexes in Middle East & North Africa (developing only) in 2010 to that in 2011?
Your response must be concise. 0.97. What is the ratio of the Number of enrolments of both sexes of Bosnia and Herzegovina in 2010 to that in 2011?
Give a very brief answer. 1.02. What is the ratio of the Number of enrolments of both sexes of India in 2010 to that in 2011?
Give a very brief answer. 0.95. What is the ratio of the Number of enrolments of both sexes of Netherlands in 2010 to that in 2011?
Your answer should be very brief. 0.96. What is the ratio of the Number of enrolments of both sexes of Middle East & North Africa (developing only) in 2010 to that in 2012?
Provide a succinct answer. 0.97. What is the ratio of the Number of enrolments of both sexes in Bosnia and Herzegovina in 2010 to that in 2012?
Offer a very short reply. 1.03. What is the ratio of the Number of enrolments of both sexes of India in 2010 to that in 2012?
Provide a succinct answer. 0.9. What is the ratio of the Number of enrolments of both sexes in Netherlands in 2010 to that in 2012?
Give a very brief answer. 0.95. What is the ratio of the Number of enrolments of both sexes in Middle East & North Africa (developing only) in 2011 to that in 2012?
Offer a terse response. 1. What is the ratio of the Number of enrolments of both sexes in Bosnia and Herzegovina in 2011 to that in 2012?
Your answer should be very brief. 1.01. What is the ratio of the Number of enrolments of both sexes in India in 2011 to that in 2012?
Keep it short and to the point. 0.95. What is the difference between the highest and the second highest Number of enrolments of both sexes in Middle East & North Africa (developing only)?
Provide a short and direct response. 3830. What is the difference between the highest and the second highest Number of enrolments of both sexes in Bosnia and Herzegovina?
Give a very brief answer. 4616. What is the difference between the highest and the second highest Number of enrolments of both sexes in India?
Ensure brevity in your answer.  5.42e+06. What is the difference between the highest and the second highest Number of enrolments of both sexes in Netherlands?
Offer a terse response. 1.13e+04. What is the difference between the highest and the lowest Number of enrolments of both sexes in Middle East & North Africa (developing only)?
Keep it short and to the point. 1.08e+06. What is the difference between the highest and the lowest Number of enrolments of both sexes in Bosnia and Herzegovina?
Ensure brevity in your answer.  2.56e+04. What is the difference between the highest and the lowest Number of enrolments of both sexes of India?
Provide a succinct answer. 2.31e+07. What is the difference between the highest and the lowest Number of enrolments of both sexes of Netherlands?
Provide a short and direct response. 1.06e+05. 